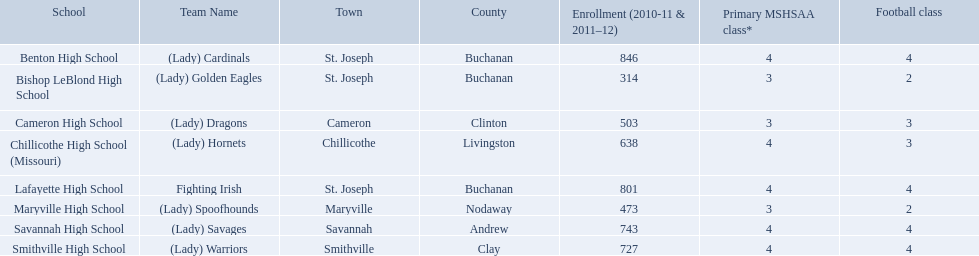What schools are located in st. joseph? Benton High School, Bishop LeBlond High School, Lafayette High School. Which st. joseph schools have more then 800 enrollment  for 2010-11 7 2011-12? Benton High School, Lafayette High School. I'm looking to parse the entire table for insights. Could you assist me with that? {'header': ['School', 'Team Name', 'Town', 'County', 'Enrollment (2010-11 & 2011–12)', 'Primary MSHSAA class*', 'Football class'], 'rows': [['Benton High School', '(Lady) Cardinals', 'St. Joseph', 'Buchanan', '846', '4', '4'], ['Bishop LeBlond High School', '(Lady) Golden Eagles', 'St. Joseph', 'Buchanan', '314', '3', '2'], ['Cameron High School', '(Lady) Dragons', 'Cameron', 'Clinton', '503', '3', '3'], ['Chillicothe High School (Missouri)', '(Lady) Hornets', 'Chillicothe', 'Livingston', '638', '4', '3'], ['Lafayette High School', 'Fighting Irish', 'St. Joseph', 'Buchanan', '801', '4', '4'], ['Maryville High School', '(Lady) Spoofhounds', 'Maryville', 'Nodaway', '473', '3', '2'], ['Savannah High School', '(Lady) Savages', 'Savannah', 'Andrew', '743', '4', '4'], ['Smithville High School', '(Lady) Warriors', 'Smithville', 'Clay', '727', '4', '4']]} What is the name of the st. joseph school with 800 or more enrollment's team names is a not a (lady)? Lafayette High School. What is the lowest number of students enrolled at a school as listed here? 314. What school has 314 students enrolled? Bishop LeBlond High School. Would you mind parsing the complete table? {'header': ['School', 'Team Name', 'Town', 'County', 'Enrollment (2010-11 & 2011–12)', 'Primary MSHSAA class*', 'Football class'], 'rows': [['Benton High School', '(Lady) Cardinals', 'St. Joseph', 'Buchanan', '846', '4', '4'], ['Bishop LeBlond High School', '(Lady) Golden Eagles', 'St. Joseph', 'Buchanan', '314', '3', '2'], ['Cameron High School', '(Lady) Dragons', 'Cameron', 'Clinton', '503', '3', '3'], ['Chillicothe High School (Missouri)', '(Lady) Hornets', 'Chillicothe', 'Livingston', '638', '4', '3'], ['Lafayette High School', 'Fighting Irish', 'St. Joseph', 'Buchanan', '801', '4', '4'], ['Maryville High School', '(Lady) Spoofhounds', 'Maryville', 'Nodaway', '473', '3', '2'], ['Savannah High School', '(Lady) Savages', 'Savannah', 'Andrew', '743', '4', '4'], ['Smithville High School', '(Lady) Warriors', 'Smithville', 'Clay', '727', '4', '4']]} In the midland empire conference, which school has 846 students signed up? Benton High School. Which school has 314 students signed up? Bishop LeBlond High School. Which school had 638 students signed up? Chillicothe High School (Missouri). What are the designations of the schools? Benton High School, Bishop LeBlond High School, Cameron High School, Chillicothe High School (Missouri), Lafayette High School, Maryville High School, Savannah High School, Smithville High School. Of these, which had a total admission of under 500? Bishop LeBlond High School, Maryville High School. And of those, which had the lowest number of enrollees? Bishop LeBlond High School. What is the minimum number of students registered at a school as mentioned here? 314. Which school has 314 pupils registered? Bishop LeBlond High School. What are all the educational establishments? Benton High School, Bishop LeBlond High School, Cameron High School, Chillicothe High School (Missouri), Lafayette High School, Maryville High School, Savannah High School, Smithville High School. How many football lessons do they feature? 4, 2, 3, 3, 4, 2, 4, 4. What about their student population? 846, 314, 503, 638, 801, 473, 743, 727. Which establishments have 3 football lessons? Cameron High School, Chillicothe High School (Missouri). And of those establishments, which has 638 attendees? Chillicothe High School (Missouri). What are the titles of the academies? Benton High School, Bishop LeBlond High School, Cameron High School, Chillicothe High School (Missouri), Lafayette High School, Maryville High School, Savannah High School, Smithville High School. Would you be able to parse every entry in this table? {'header': ['School', 'Team Name', 'Town', 'County', 'Enrollment (2010-11 & 2011–12)', 'Primary MSHSAA class*', 'Football class'], 'rows': [['Benton High School', '(Lady) Cardinals', 'St. Joseph', 'Buchanan', '846', '4', '4'], ['Bishop LeBlond High School', '(Lady) Golden Eagles', 'St. Joseph', 'Buchanan', '314', '3', '2'], ['Cameron High School', '(Lady) Dragons', 'Cameron', 'Clinton', '503', '3', '3'], ['Chillicothe High School (Missouri)', '(Lady) Hornets', 'Chillicothe', 'Livingston', '638', '4', '3'], ['Lafayette High School', 'Fighting Irish', 'St. Joseph', 'Buchanan', '801', '4', '4'], ['Maryville High School', '(Lady) Spoofhounds', 'Maryville', 'Nodaway', '473', '3', '2'], ['Savannah High School', '(Lady) Savages', 'Savannah', 'Andrew', '743', '4', '4'], ['Smithville High School', '(Lady) Warriors', 'Smithville', 'Clay', '727', '4', '4']]} Of these, which had a cumulative enrollment of less than 500? Bishop LeBlond High School, Maryville High School. And of those, which had the least enrollment? Bishop LeBlond High School. What academic institution in midland empire conference has 846 learners enrolled? Benton High School. What academic institution has 314 learners enrolled? Bishop LeBlond High School. What academic institution had 638 learners enrolled? Chillicothe High School (Missouri). Would you be able to parse every entry in this table? {'header': ['School', 'Team Name', 'Town', 'County', 'Enrollment (2010-11 & 2011–12)', 'Primary MSHSAA class*', 'Football class'], 'rows': [['Benton High School', '(Lady) Cardinals', 'St. Joseph', 'Buchanan', '846', '4', '4'], ['Bishop LeBlond High School', '(Lady) Golden Eagles', 'St. Joseph', 'Buchanan', '314', '3', '2'], ['Cameron High School', '(Lady) Dragons', 'Cameron', 'Clinton', '503', '3', '3'], ['Chillicothe High School (Missouri)', '(Lady) Hornets', 'Chillicothe', 'Livingston', '638', '4', '3'], ['Lafayette High School', 'Fighting Irish', 'St. Joseph', 'Buchanan', '801', '4', '4'], ['Maryville High School', '(Lady) Spoofhounds', 'Maryville', 'Nodaway', '473', '3', '2'], ['Savannah High School', '(Lady) Savages', 'Savannah', 'Andrew', '743', '4', '4'], ['Smithville High School', '(Lady) Warriors', 'Smithville', 'Clay', '727', '4', '4']]} What are the three educational institutions in the town of st. joseph? St. Joseph, St. Joseph, St. Joseph. Of the three institutions in st. joseph, which one's team name does not represent a kind of animal? Lafayette High School. What are the schools situated in st. joseph? Benton High School, Bishop LeBlond High School, Lafayette High School. In the 2010-11 and 2011-12 academic years, which st. joseph schools had an enrollment of more than 800 students? Benton High School, Lafayette High School. What is the name of the st. joseph school that has 800 or more enrollments and a team name that does not have "lady" in it? Lafayette High School. Can you give me this table in json format? {'header': ['School', 'Team Name', 'Town', 'County', 'Enrollment (2010-11 & 2011–12)', 'Primary MSHSAA class*', 'Football class'], 'rows': [['Benton High School', '(Lady) Cardinals', 'St. Joseph', 'Buchanan', '846', '4', '4'], ['Bishop LeBlond High School', '(Lady) Golden Eagles', 'St. Joseph', 'Buchanan', '314', '3', '2'], ['Cameron High School', '(Lady) Dragons', 'Cameron', 'Clinton', '503', '3', '3'], ['Chillicothe High School (Missouri)', '(Lady) Hornets', 'Chillicothe', 'Livingston', '638', '4', '3'], ['Lafayette High School', 'Fighting Irish', 'St. Joseph', 'Buchanan', '801', '4', '4'], ['Maryville High School', '(Lady) Spoofhounds', 'Maryville', 'Nodaway', '473', '3', '2'], ['Savannah High School', '(Lady) Savages', 'Savannah', 'Andrew', '743', '4', '4'], ['Smithville High School', '(Lady) Warriors', 'Smithville', 'Clay', '727', '4', '4']]} In st. joseph, which schools can be found? Benton High School, Bishop LeBlond High School, Lafayette High School. Which st. joseph schools had enrollments exceeding 800 during the academic years 2010-11 and 2011-12? Benton High School, Lafayette High School. What is the name of the st. joseph school that has 800 or more enroll? Lafayette High School. Can you provide a list of all the schools? Benton High School, Bishop LeBlond High School, Cameron High School, Chillicothe High School (Missouri), Lafayette High School, Maryville High School, Savannah High School, Smithville High School. How many football programs are available at each school? 4, 2, 3, 3, 4, 2, 4, 4. What are their student registration numbers? 846, 314, 503, 638, 801, 473, 743, 727. Which schools feature three football classes? Cameron High School, Chillicothe High School (Missouri). Out of those schools, which has a total of 638 students? Chillicothe High School (Missouri). In the midland empire conference, which school has a student population of 846? Benton High School. 314? Bishop LeBlond High School. And 638? Chillicothe High School (Missouri). At every school, what is the total number of enrolled students? Benton High School, 846, Bishop LeBlond High School, 314, Cameron High School, 503, Chillicothe High School (Missouri), 638, Lafayette High School, 801, Maryville High School, 473, Savannah High School, 743, Smithville High School, 727. In which school are there precisely three football classes? Cameron High School, 3, Chillicothe High School (Missouri), 3. Which educational establishment has an enrollment of 638 and three football classes? Chillicothe High School (Missouri). What are the names of the educational institutions? Benton High School, Bishop LeBlond High School, Cameron High School, Chillicothe High School (Missouri), Lafayette High School, Maryville High School, Savannah High School, Smithville High School. Among them, which ones have a total enrollment of fewer than 500 students? Bishop LeBlond High School, Maryville High School. And among those, which one has the smallest number of enrolled students? Bishop LeBlond High School. Parse the table in full. {'header': ['School', 'Team Name', 'Town', 'County', 'Enrollment (2010-11 & 2011–12)', 'Primary MSHSAA class*', 'Football class'], 'rows': [['Benton High School', '(Lady) Cardinals', 'St. Joseph', 'Buchanan', '846', '4', '4'], ['Bishop LeBlond High School', '(Lady) Golden Eagles', 'St. Joseph', 'Buchanan', '314', '3', '2'], ['Cameron High School', '(Lady) Dragons', 'Cameron', 'Clinton', '503', '3', '3'], ['Chillicothe High School (Missouri)', '(Lady) Hornets', 'Chillicothe', 'Livingston', '638', '4', '3'], ['Lafayette High School', 'Fighting Irish', 'St. Joseph', 'Buchanan', '801', '4', '4'], ['Maryville High School', '(Lady) Spoofhounds', 'Maryville', 'Nodaway', '473', '3', '2'], ['Savannah High School', '(Lady) Savages', 'Savannah', 'Andrew', '743', '4', '4'], ['Smithville High School', '(Lady) Warriors', 'Smithville', 'Clay', '727', '4', '4']]} What is the smallest enrollment figure for a school in this list? 314. Which educational institution has 314 students registered? Bishop LeBlond High School. What is the least number of students attending a school as shown here? 314. What school consists of 314 enrolled students? Bishop LeBlond High School. 